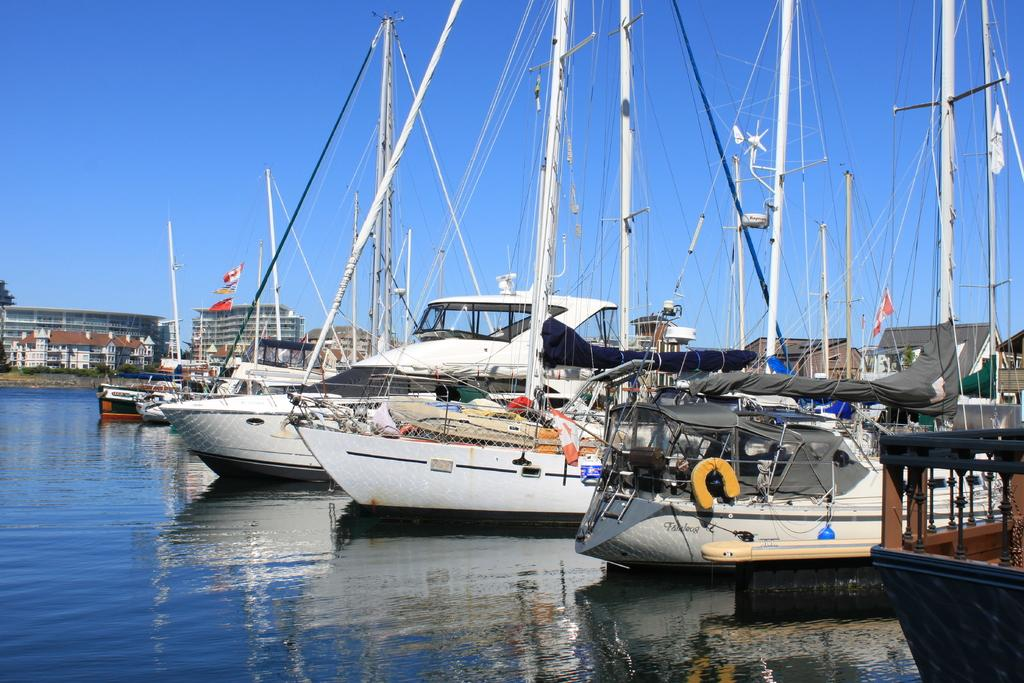What is on the water surface in the image? There are boats on the water surface in the image. What else can be seen in the image besides the boats? There are buildings visible in the image. What is visible in the sky in the image? Clouds are present in the sky in the image. What type of plantation can be seen in the image? There is no plantation present in the image. What is the crack in the image? There is no crack visible in the image. 